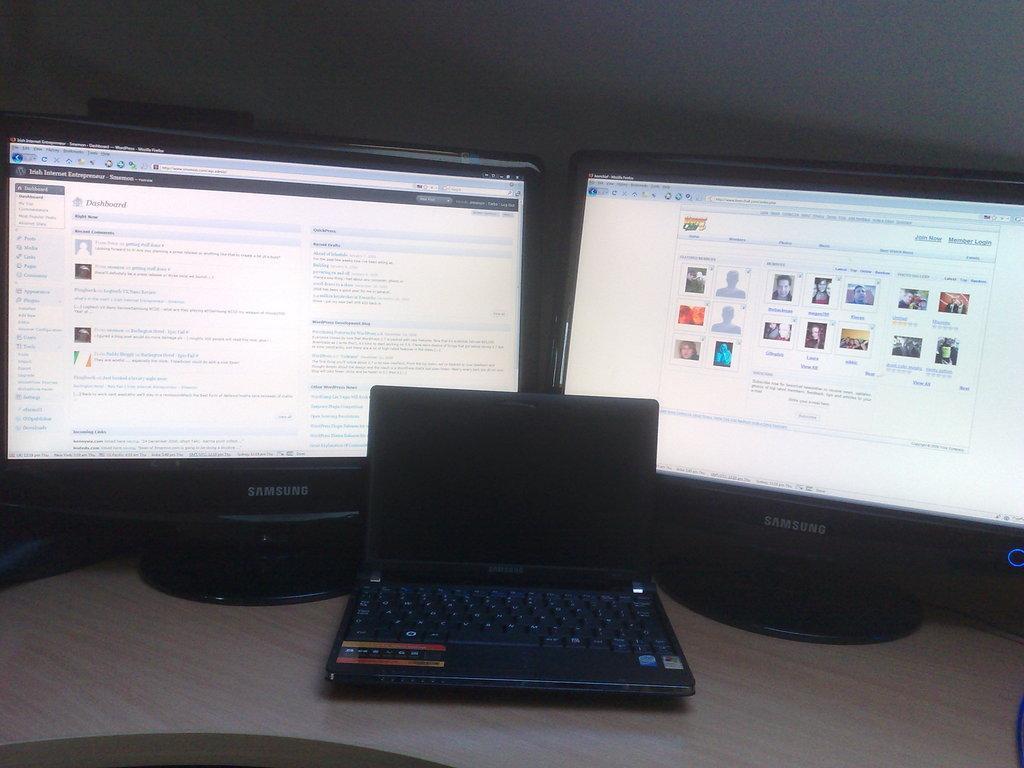Can you describe this image briefly? In this picture we can see monitors and laptop on the table. In the background of the image we can see wall. 